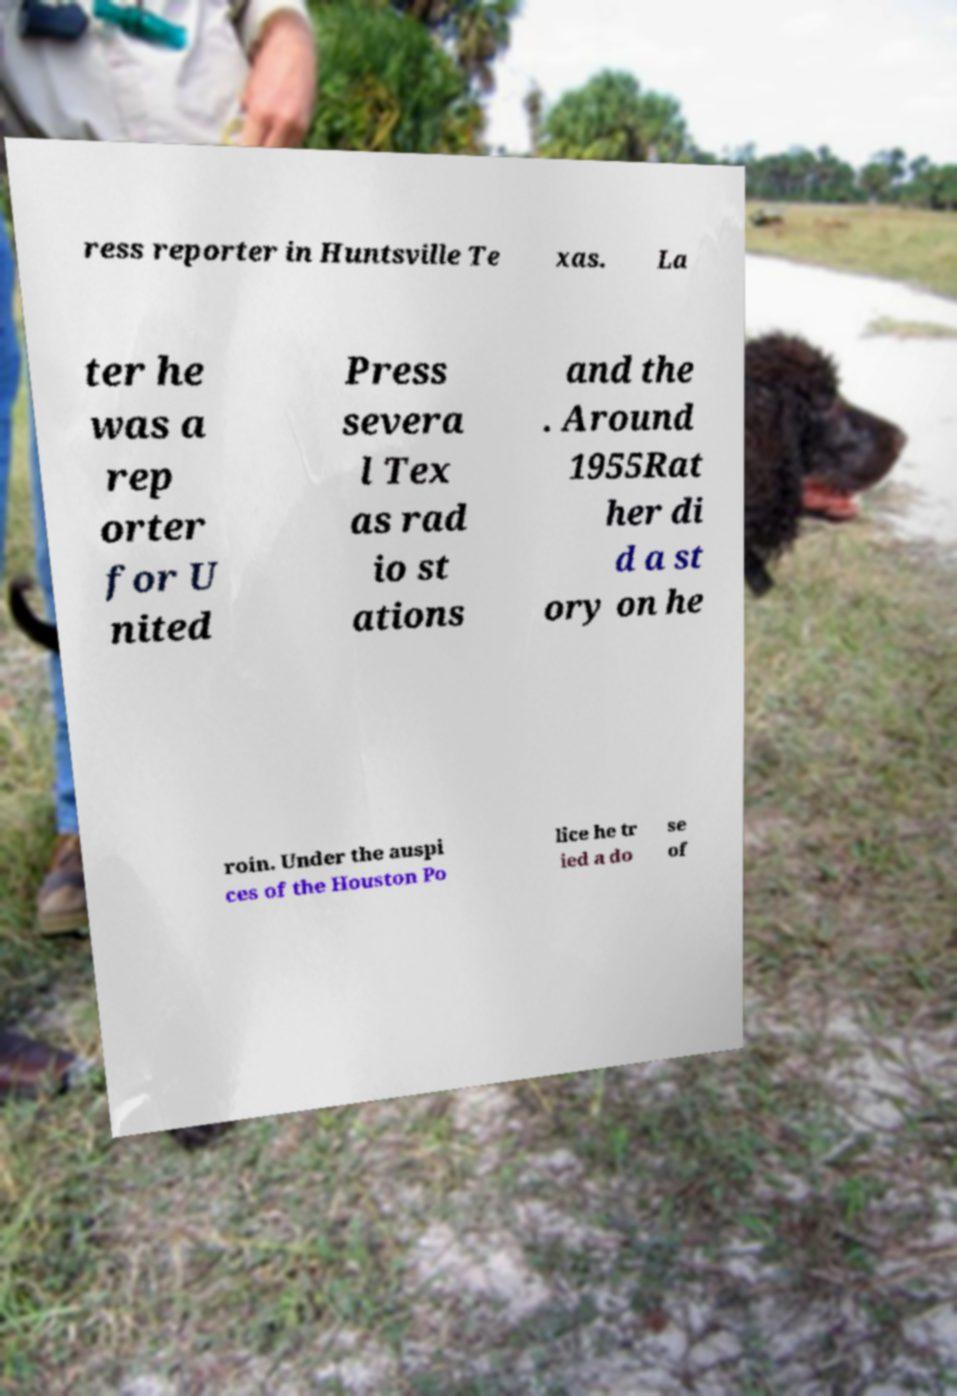There's text embedded in this image that I need extracted. Can you transcribe it verbatim? ress reporter in Huntsville Te xas. La ter he was a rep orter for U nited Press severa l Tex as rad io st ations and the . Around 1955Rat her di d a st ory on he roin. Under the auspi ces of the Houston Po lice he tr ied a do se of 